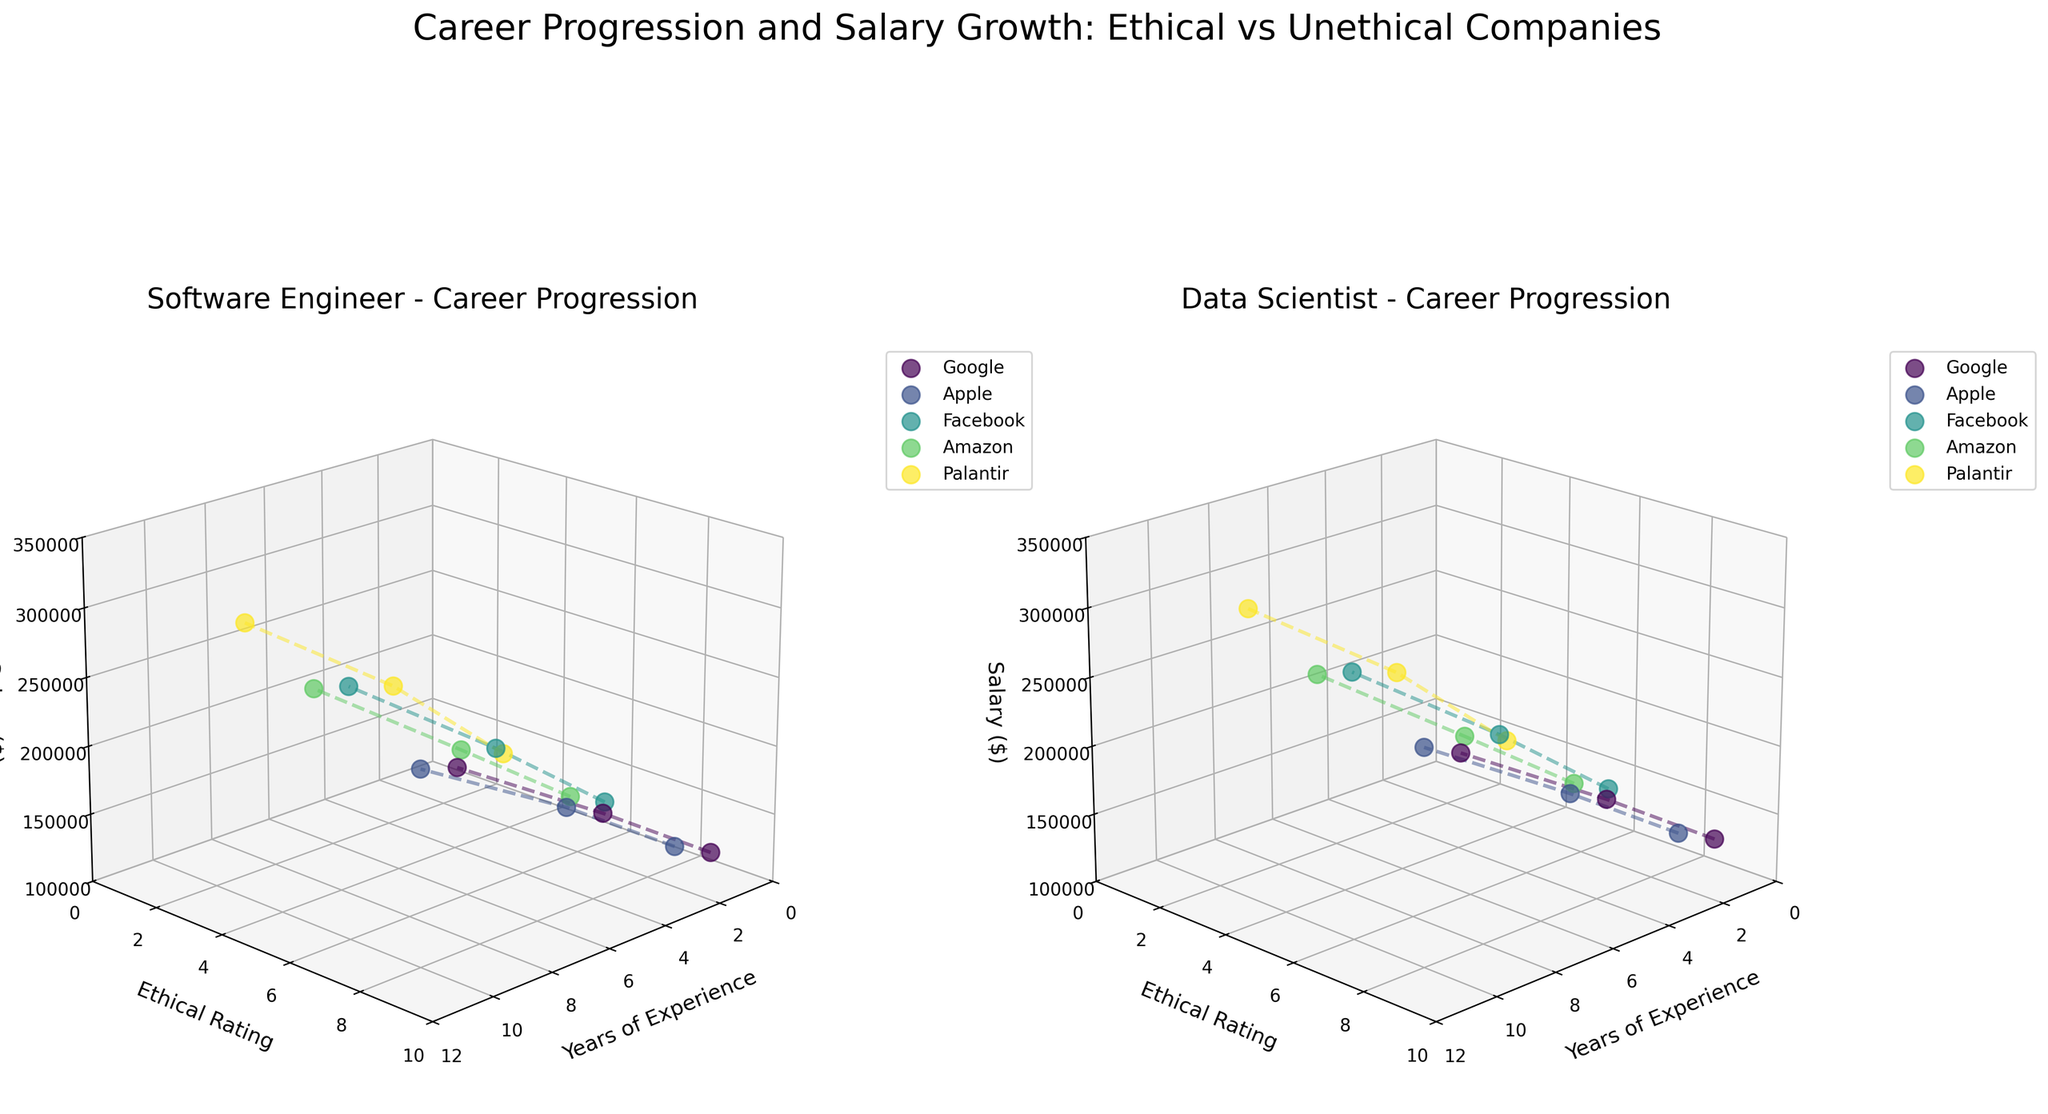What are the titles of the subplots in the figure? The figure has two subplots, one for each job role (Software Engineer and Data Scientist). By looking at each subplot, we can see the titles mention the specific roles followed by "Career Progression." This helps us identify what each subplot represents.
Answer: Software Engineer - Career Progression and Data Scientist - Career Progression Which company has the highest starting salary for Data Scientists? By observing the subplot for Data Scientists, we can examine the y-axis values for each company when the x-axis (Years of Experience) is at 1. The company with the highest z-axis value (Salary) will be the one with the highest starting salary. Palantir shows the highest point at the start.
Answer: Palantir What is the general trend of salaries in relation to years of experience in ethical companies like Google and Apple? By analyzing the trends within the subplots, we can see the plot lines for Google and Apple. Following these plot lines, we can observe that the salaries increase as the years of experience (x-axis) increase in both companies, which indicates a positive correlation.
Answer: Increase How does the ethical rating impact the salary progression in the companies displayed? Examining the z-axis (Salary) in relation to the y-axis (Ethical Ratings) across both subplots, it can be discerned that companies with higher ethical ratings like Google and Apple show a steady and substantial increase in salary. Conversely, companies with lower ratings like Palantir and Amazon show a steeper increase, indicating that ethical ratings might impact salary progression differently.
Answer: Higher ethical ratings show steady increase; lower ethical ratings show steeper increase Compare the endpoint salaries (with 10 years of experience) for Software Engineers between Google and Palantir. Looking at the subplot for Software Engineers at the x-axis value of 10 (indicating 10 years of experience), we check the z-axis values (Salary) for Google and Palantir. For Google, the salary is 250,000, and for Palantir, it is 300,000.
Answer: Google: 250,000, Palantir: 300,000 What common characteristic can be observed among all companies in the way they depict salary growth over time? Observing the trends for all companies across both subplots, we can see that the salary (z-axis) consistently increases as the years of experience (x-axis) increase. This indicates that salary growth over time is a common characteristic regardless of the company's ethical rating or job role.
Answer: Salary consistently increases over time Which job role generally shows higher salaries with the same years of experience across all companies? By comparing both subplots, we need to look at the height of the z-axis (Salary) for both roles at various points along the x-axis (Years of Experience). The role that consistently shows higher z-values will have the higher salaries. Data Scientist roles show higher points across the majority of cases.
Answer: Data Scientist What is the ethical rating of Palantir, and how does it compare to Google? We can look at the y-axis values to identify the ethical ratings for both companies. Palantir's ethical rating is consistently at 3, while Google's is at 9. This stark contrast highlights the differences in their ethical standings.
Answer: Palantir: 3, Google: 9 